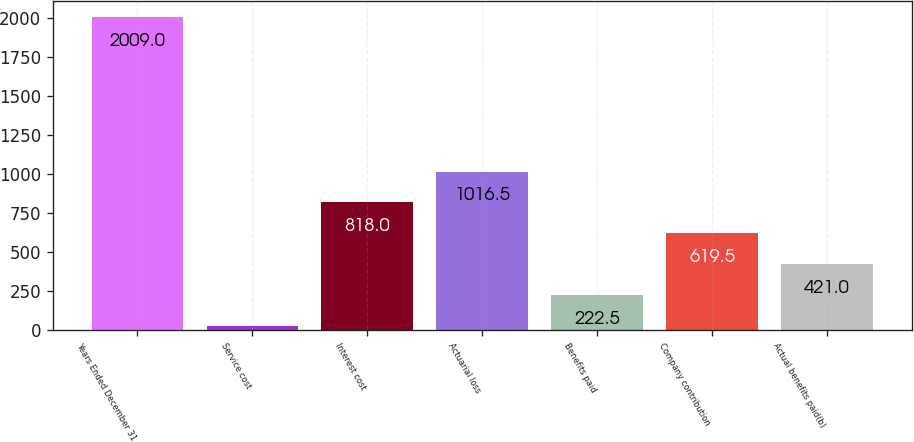<chart> <loc_0><loc_0><loc_500><loc_500><bar_chart><fcel>Years Ended December 31<fcel>Service cost<fcel>Interest cost<fcel>Actuarial loss<fcel>Benefits paid<fcel>Company contribution<fcel>Actual benefits paid(b)<nl><fcel>2009<fcel>24<fcel>818<fcel>1016.5<fcel>222.5<fcel>619.5<fcel>421<nl></chart> 